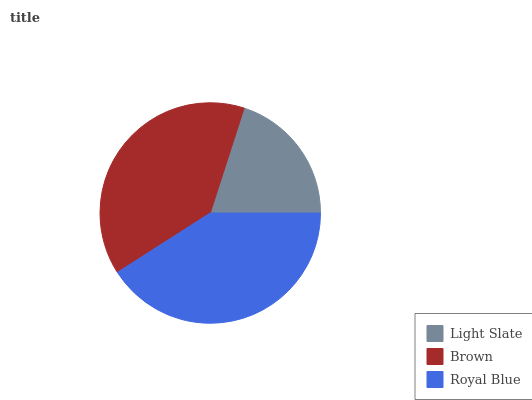Is Light Slate the minimum?
Answer yes or no. Yes. Is Royal Blue the maximum?
Answer yes or no. Yes. Is Brown the minimum?
Answer yes or no. No. Is Brown the maximum?
Answer yes or no. No. Is Brown greater than Light Slate?
Answer yes or no. Yes. Is Light Slate less than Brown?
Answer yes or no. Yes. Is Light Slate greater than Brown?
Answer yes or no. No. Is Brown less than Light Slate?
Answer yes or no. No. Is Brown the high median?
Answer yes or no. Yes. Is Brown the low median?
Answer yes or no. Yes. Is Royal Blue the high median?
Answer yes or no. No. Is Light Slate the low median?
Answer yes or no. No. 